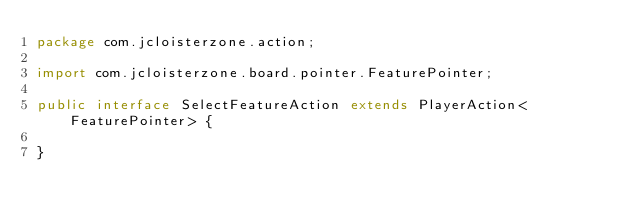<code> <loc_0><loc_0><loc_500><loc_500><_Java_>package com.jcloisterzone.action;

import com.jcloisterzone.board.pointer.FeaturePointer;

public interface SelectFeatureAction extends PlayerAction<FeaturePointer> {

}
</code> 